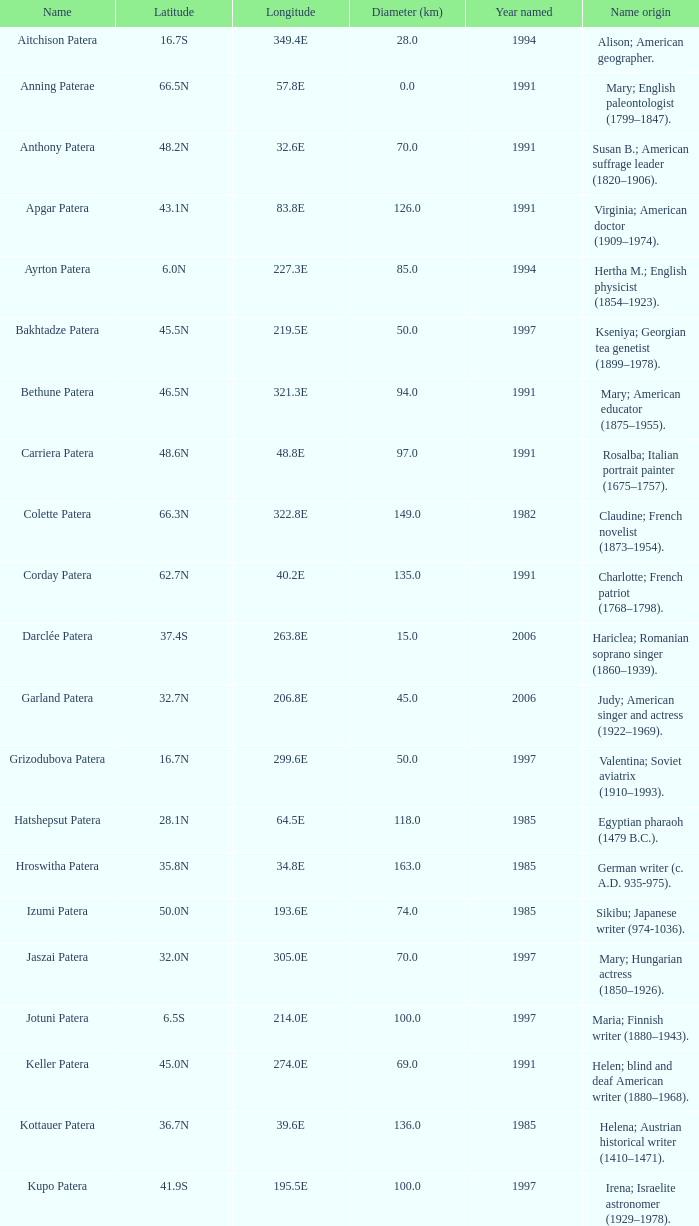What is the width in km of the feature known as colette patera? 149.0. 